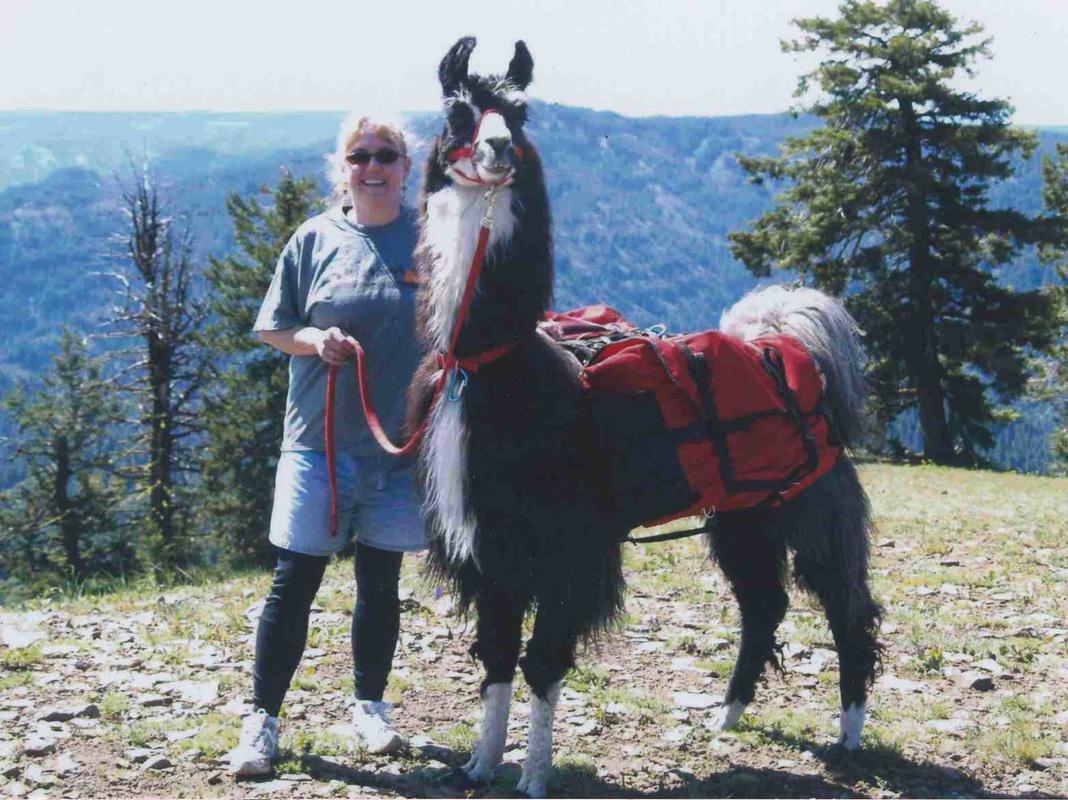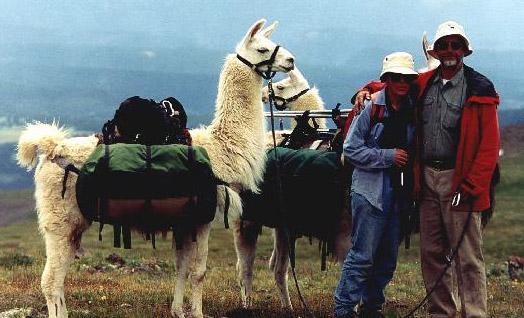The first image is the image on the left, the second image is the image on the right. Considering the images on both sides, is "In one image, a single person is posing to the left of an alpaca." valid? Answer yes or no. Yes. The first image is the image on the left, the second image is the image on the right. Evaluate the accuracy of this statement regarding the images: "In one image, exactly one forward-facing person in sunglasses is standing on an overlook next to the front-end of a llama with its body turned leftward.". Is it true? Answer yes or no. Yes. 